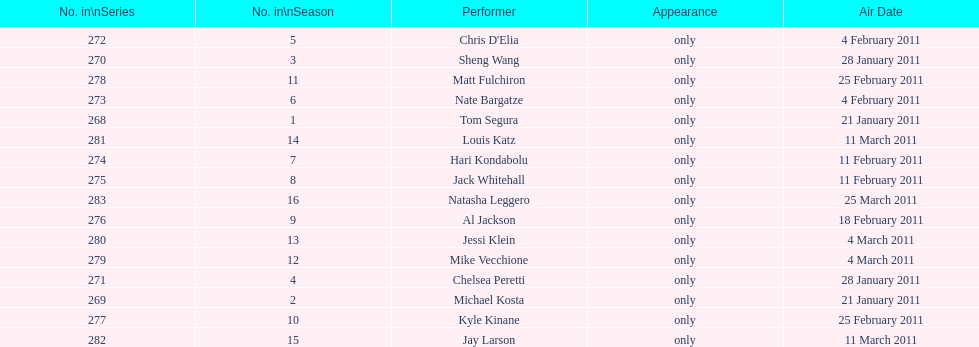What is the name of the last performer on this chart? Natasha Leggero. Could you help me parse every detail presented in this table? {'header': ['No. in\\nSeries', 'No. in\\nSeason', 'Performer', 'Appearance', 'Air Date'], 'rows': [['272', '5', "Chris D'Elia", 'only', '4 February 2011'], ['270', '3', 'Sheng Wang', 'only', '28 January 2011'], ['278', '11', 'Matt Fulchiron', 'only', '25 February 2011'], ['273', '6', 'Nate Bargatze', 'only', '4 February 2011'], ['268', '1', 'Tom Segura', 'only', '21 January 2011'], ['281', '14', 'Louis Katz', 'only', '11 March 2011'], ['274', '7', 'Hari Kondabolu', 'only', '11 February 2011'], ['275', '8', 'Jack Whitehall', 'only', '11 February 2011'], ['283', '16', 'Natasha Leggero', 'only', '25 March 2011'], ['276', '9', 'Al Jackson', 'only', '18 February 2011'], ['280', '13', 'Jessi Klein', 'only', '4 March 2011'], ['279', '12', 'Mike Vecchione', 'only', '4 March 2011'], ['271', '4', 'Chelsea Peretti', 'only', '28 January 2011'], ['269', '2', 'Michael Kosta', 'only', '21 January 2011'], ['277', '10', 'Kyle Kinane', 'only', '25 February 2011'], ['282', '15', 'Jay Larson', 'only', '11 March 2011']]} 